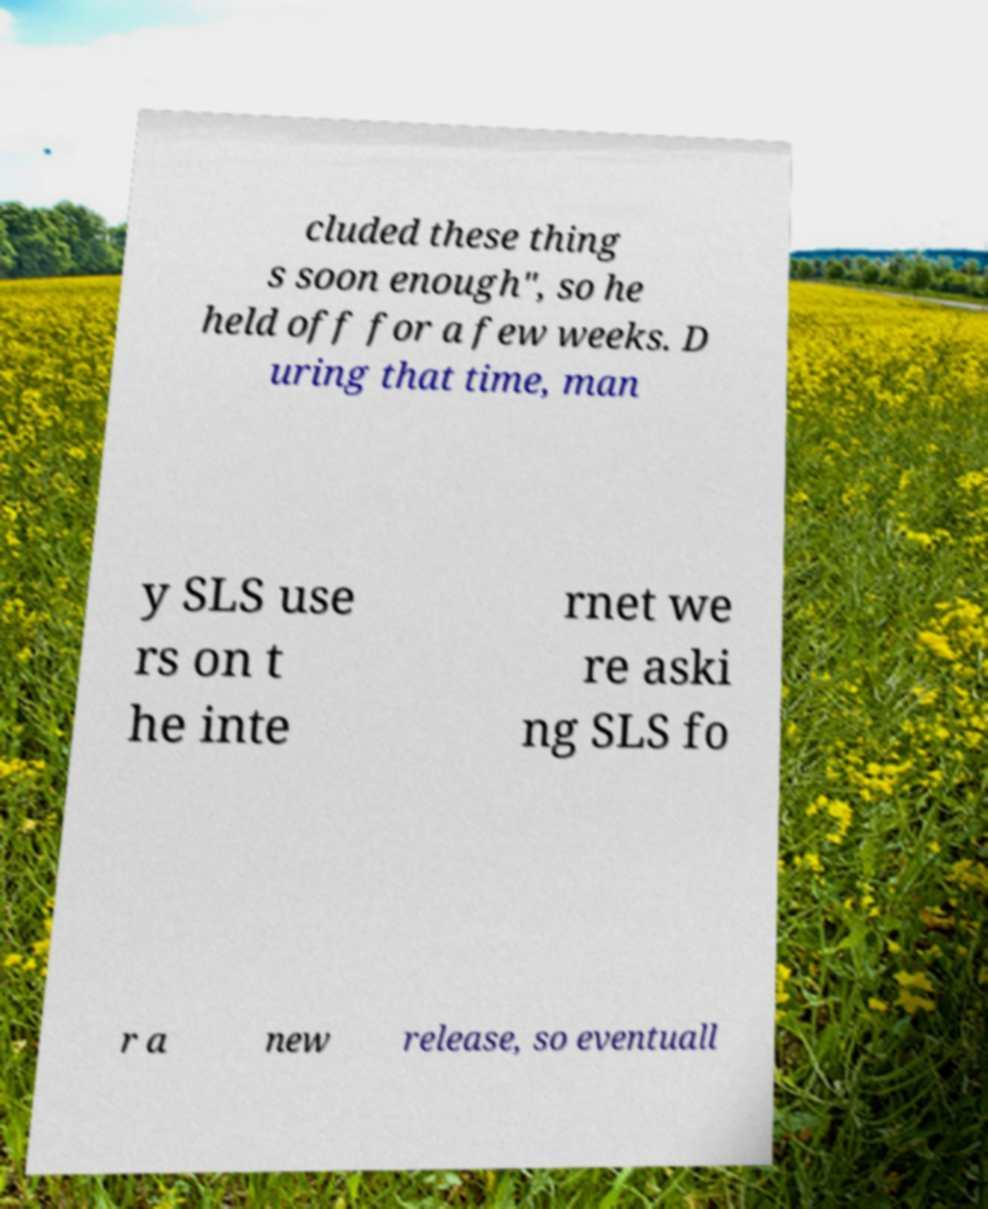Could you assist in decoding the text presented in this image and type it out clearly? cluded these thing s soon enough", so he held off for a few weeks. D uring that time, man y SLS use rs on t he inte rnet we re aski ng SLS fo r a new release, so eventuall 